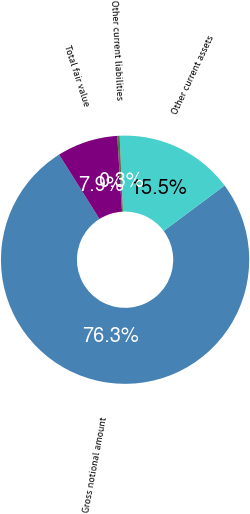Convert chart to OTSL. <chart><loc_0><loc_0><loc_500><loc_500><pie_chart><fcel>Gross notional amount<fcel>Other current assets<fcel>Other current liabilities<fcel>Total fair value<nl><fcel>76.27%<fcel>15.5%<fcel>0.31%<fcel>7.91%<nl></chart> 